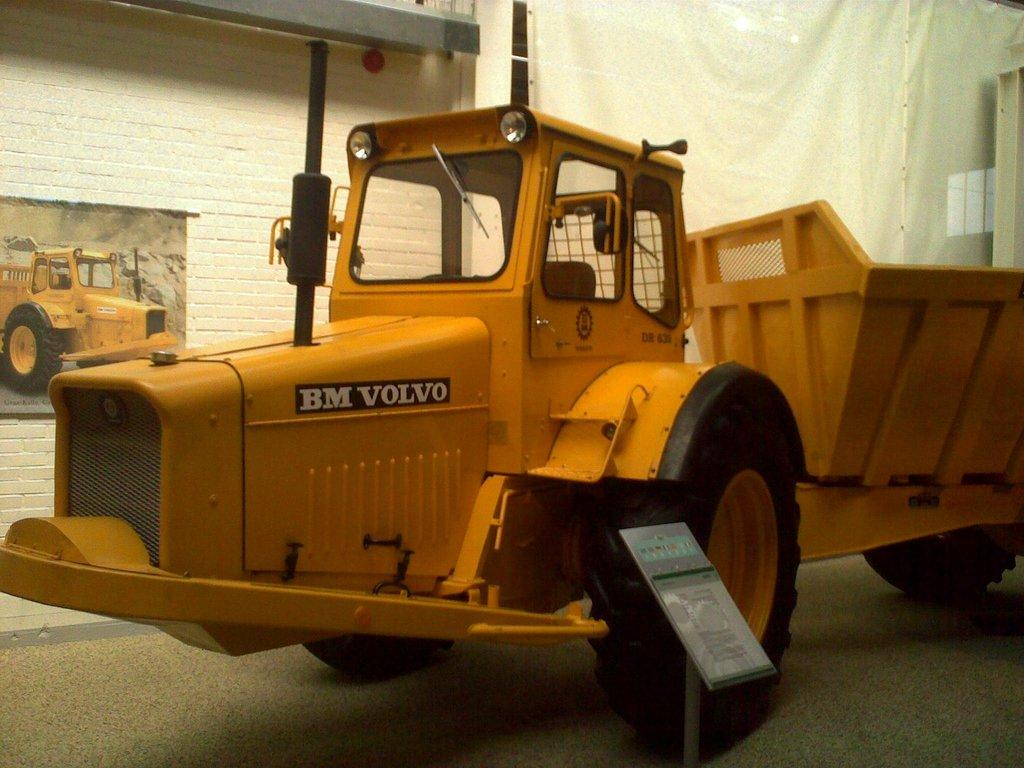What color is the vehicle in the image? The vehicle in the image is yellow. What can be seen on the vehicle besides its color? There is text written on the vehicle. What is present in the image besides the vehicle? There is a stand in the image. What can be seen in the background of the image? There is a photo of a vehicle in the background. Can you tell me how many goats are standing near the vehicle in the image? There are no goats present in the image; it only features a yellow vehicle, text on the vehicle, a stand, and a photo of a vehicle in the background. What type of brass object can be seen on the vehicle in the image? There is no brass object present on the vehicle in the image. 